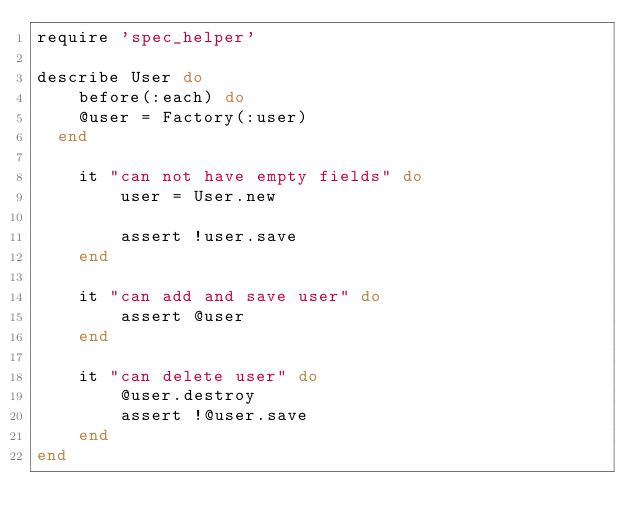<code> <loc_0><loc_0><loc_500><loc_500><_Ruby_>require 'spec_helper'

describe User do
	before(:each) do
    @user = Factory(:user)
  end
  
	it "can not have empty fields" do
		user = User.new

		assert !user.save
	end

	it "can add and save user" do
		assert @user
	end

	it "can delete user" do
		@user.destroy
		assert !@user.save
	end
end</code> 